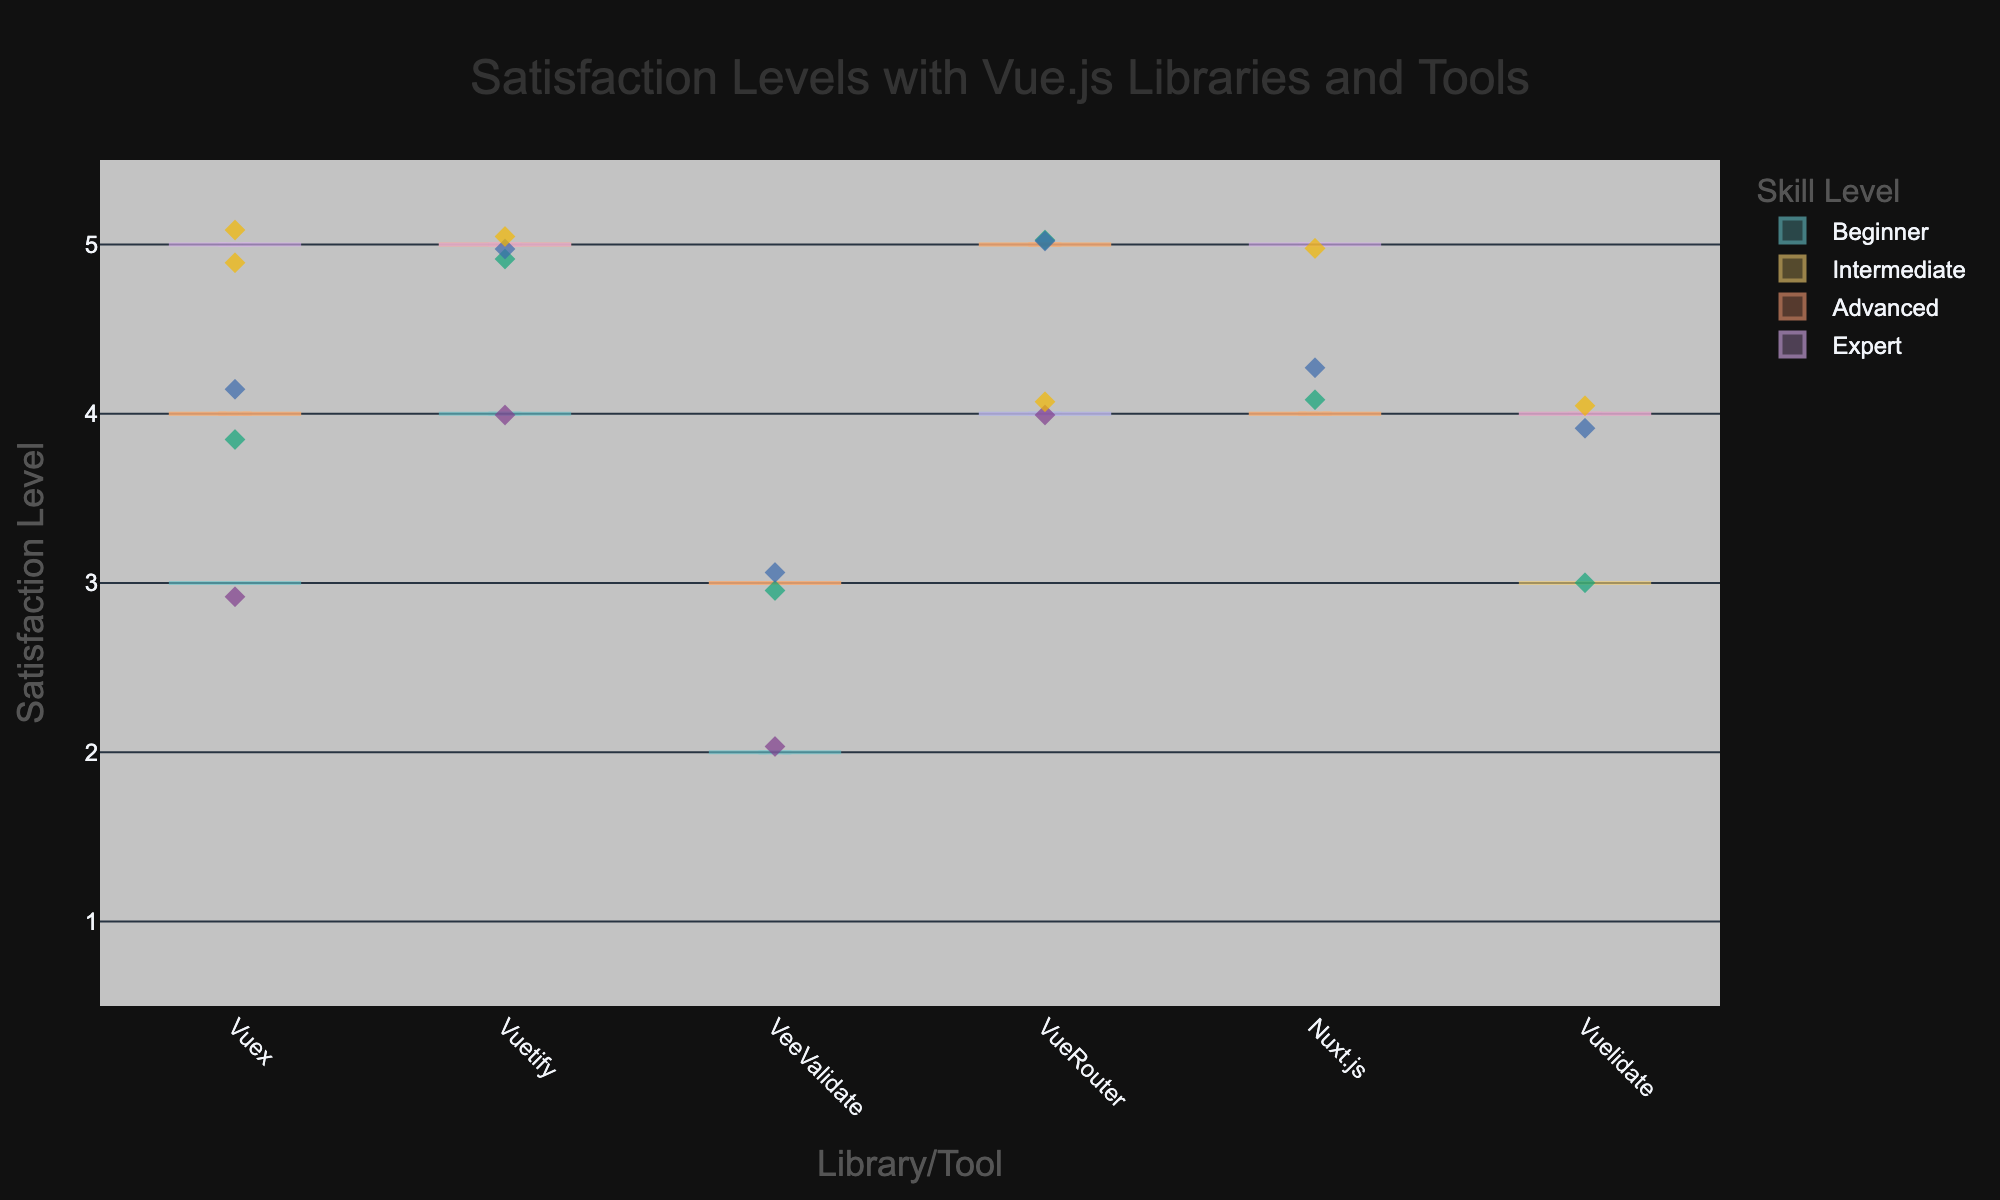What is the title of the figure? The title of the figure is displayed at the top and provides an overview of the chart. It reads "Satisfaction Levels with Vue.js Libraries and Tools".
Answer: Satisfaction Levels with Vue.js Libraries and Tools Which skill level has the highest distribution of satisfaction levels for Vuex? To determine this, look at the violin plot for Vuex and compare the width and range of the distributions among different skill levels. The widest distribution indicates the highest number of responses.
Answer: Expert What is the satisfaction level range for Nuxt.js among Beginners? Identify the violin plot section for Nuxt.js under the ‘Beginner’ skill level and observe the vertical spread of the plot. The range is given by the difference between the highest point and lowest point of the violin plot.
Answer: 4-4 How does the average satisfaction with Vuetify differ between Advanced and Intermediate developers? Locate the violin plots for Vuetify under the Advanced and Intermediate skill levels. Observe the central lines in the violins, which represent the mean satisfaction levels. Compare these lines to determine the difference.
Answer: Advanced > Intermediate Which tool has the most consistent satisfaction levels among Experts? To determine consistency, look at the narrowest violin plot among the tools for the Expert level, indicating minimal spread in satisfaction levels.
Answer: Vuex, Vuetify, Nuxt.js (all have a uniform satisfaction level of 5) Which skill level shows the most variability in satisfaction levels for VeeValidate? Variability in satisfaction can be judged by the width and spread of the violin plot for VeeValidate among different skill levels. The skill level with the widest spread has the most variability.
Answer: Advanced Compare the median satisfaction levels of VueRouter for Intermediate and Expert developers. Which one is higher? The median is represented by the central line within the violin plot. Compare the central lines for VueRouter between Intermediate and Expert skill levels.
Answer: Intermediate = Expert How many satisfaction levels were recorded for Vuelidate among Advanced developers? Look at the jittered points for Vuelidate under the Advanced skill level and count the number of individual data points.
Answer: 2 What does the box within each violin plot represent? The boxes inside the violin plots represent the interquartile range (IQR) of the data. The top of the box is the 75th percentile, and the bottom is the 25th percentile.
Answer: Interquartile range Is there a skill level that uniformly shows high satisfaction across all tools? By examining the central lines and the spread of the violin plots for each skill level across all tools, we can identify if one skill level consistently has high satisfaction.
Answer: Expert 